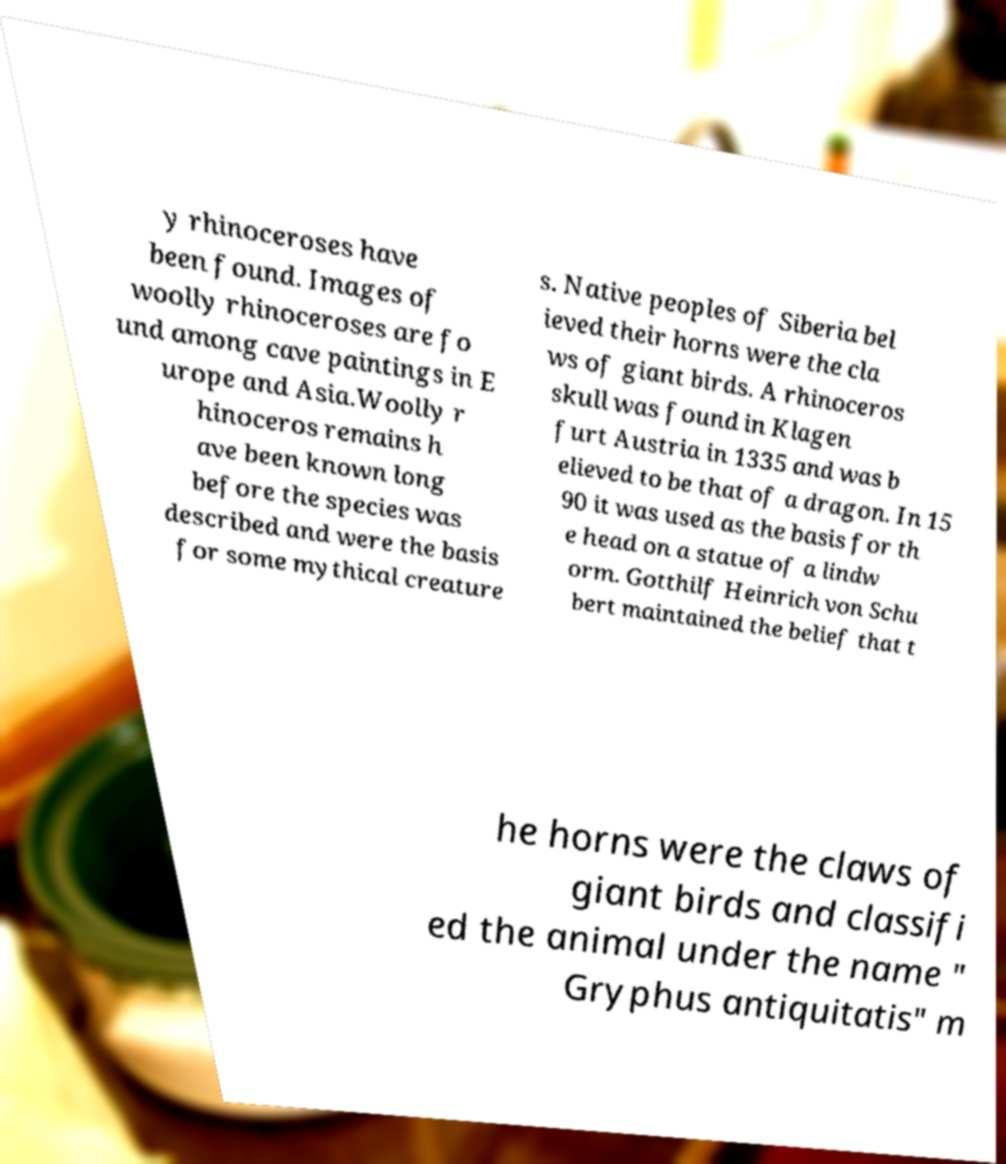Can you accurately transcribe the text from the provided image for me? y rhinoceroses have been found. Images of woolly rhinoceroses are fo und among cave paintings in E urope and Asia.Woolly r hinoceros remains h ave been known long before the species was described and were the basis for some mythical creature s. Native peoples of Siberia bel ieved their horns were the cla ws of giant birds. A rhinoceros skull was found in Klagen furt Austria in 1335 and was b elieved to be that of a dragon. In 15 90 it was used as the basis for th e head on a statue of a lindw orm. Gotthilf Heinrich von Schu bert maintained the belief that t he horns were the claws of giant birds and classifi ed the animal under the name " Gryphus antiquitatis" m 